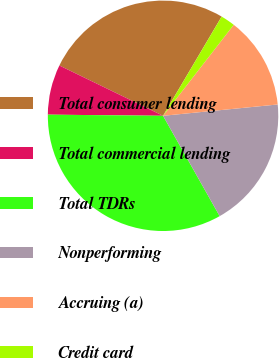<chart> <loc_0><loc_0><loc_500><loc_500><pie_chart><fcel>Total consumer lending<fcel>Total commercial lending<fcel>Total TDRs<fcel>Nonperforming<fcel>Accruing (a)<fcel>Credit card<nl><fcel>26.3%<fcel>7.03%<fcel>33.33%<fcel>18.39%<fcel>12.92%<fcel>2.02%<nl></chart> 